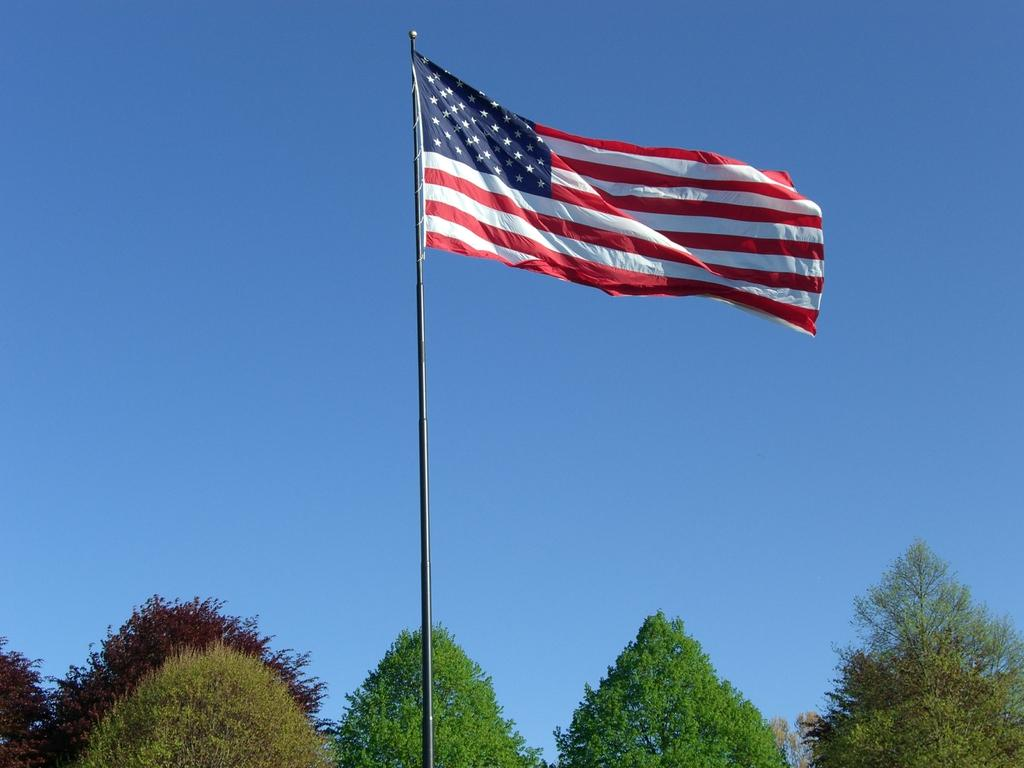What is the main subject in the center of the image? There is a flag in the center of the image. What can be seen in the background of the image? There are trees and the sky visible in the background of the image. How many wrens are perched on the flag in the image? There are no wrens present in the image; the main subject is the flag. 